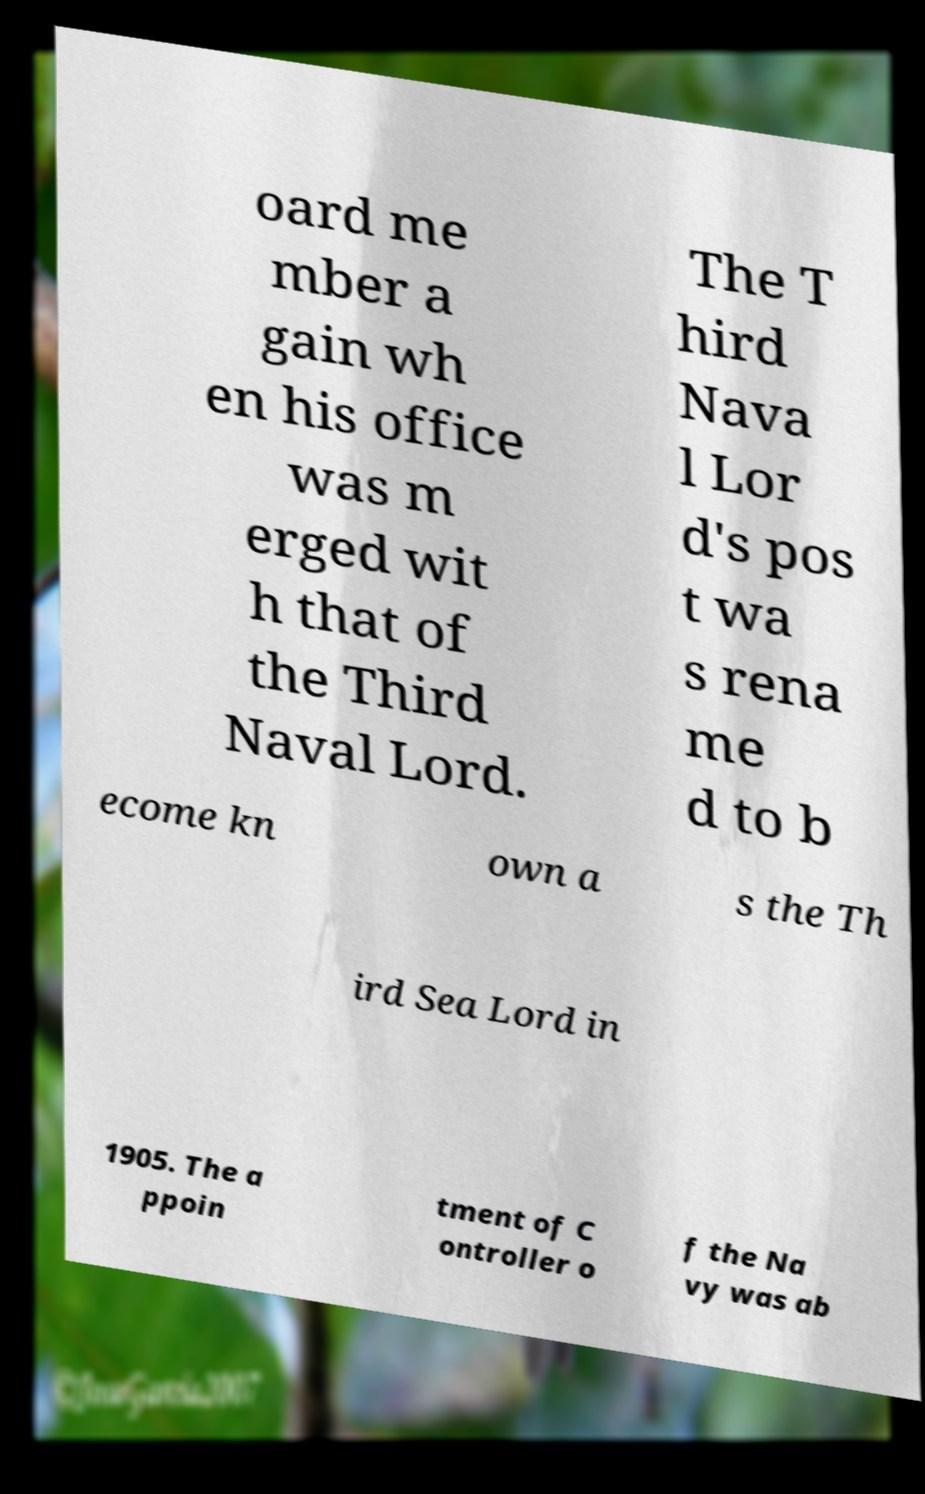For documentation purposes, I need the text within this image transcribed. Could you provide that? oard me mber a gain wh en his office was m erged wit h that of the Third Naval Lord. The T hird Nava l Lor d's pos t wa s rena me d to b ecome kn own a s the Th ird Sea Lord in 1905. The a ppoin tment of C ontroller o f the Na vy was ab 